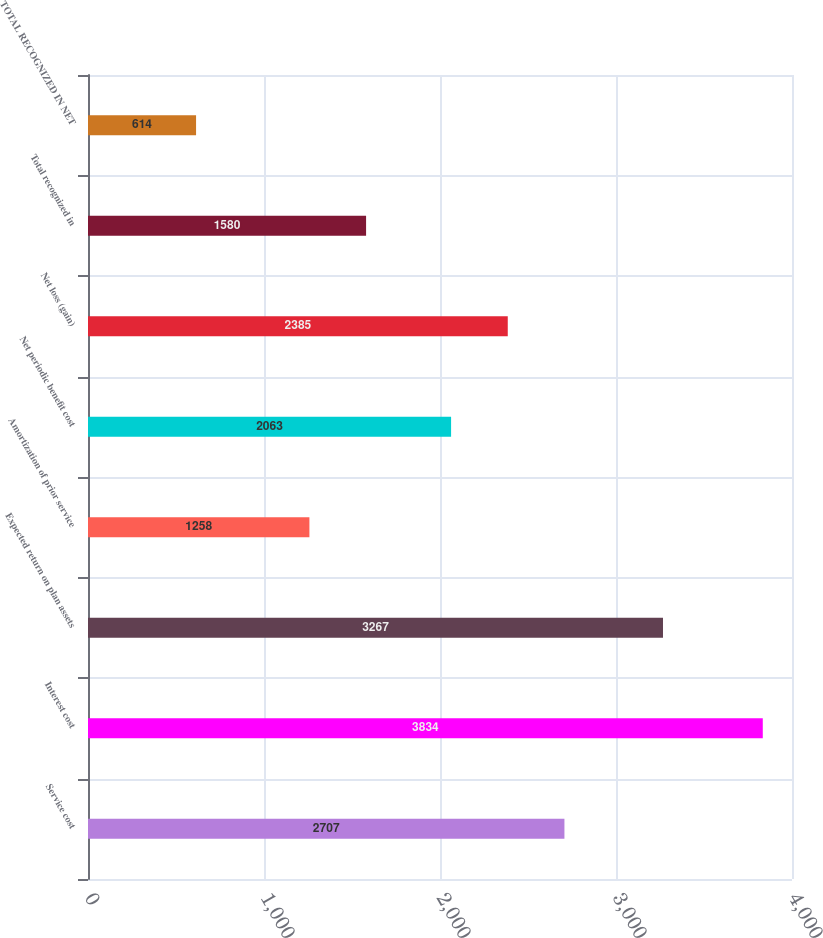Convert chart. <chart><loc_0><loc_0><loc_500><loc_500><bar_chart><fcel>Service cost<fcel>Interest cost<fcel>Expected return on plan assets<fcel>Amortization of prior service<fcel>Net periodic benefit cost<fcel>Net loss (gain)<fcel>Total recognized in<fcel>TOTAL RECOGNIZED IN NET<nl><fcel>2707<fcel>3834<fcel>3267<fcel>1258<fcel>2063<fcel>2385<fcel>1580<fcel>614<nl></chart> 